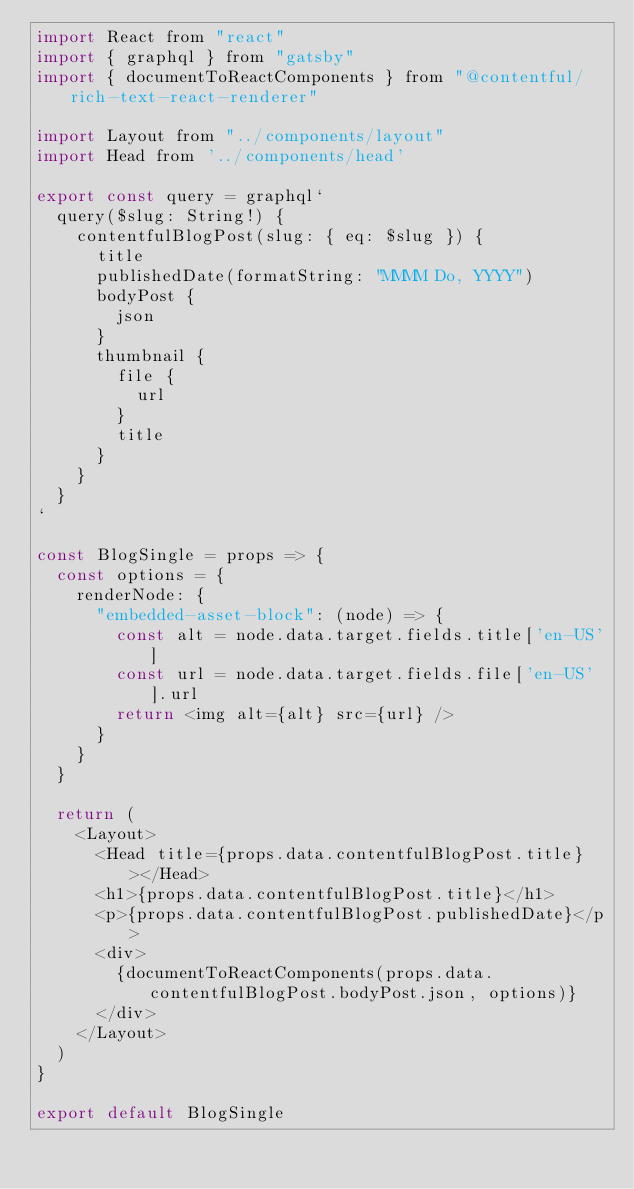<code> <loc_0><loc_0><loc_500><loc_500><_JavaScript_>import React from "react"
import { graphql } from "gatsby"
import { documentToReactComponents } from "@contentful/rich-text-react-renderer"

import Layout from "../components/layout"
import Head from '../components/head'

export const query = graphql`
  query($slug: String!) {
    contentfulBlogPost(slug: { eq: $slug }) {
      title
      publishedDate(formatString: "MMMM Do, YYYY")
      bodyPost {
        json
      }
      thumbnail {
        file {
          url
        }
        title
      }
    }
  }
`

const BlogSingle = props => {
  const options = {
    renderNode: {
      "embedded-asset-block": (node) => {
        const alt = node.data.target.fields.title['en-US']
        const url = node.data.target.fields.file['en-US'].url
        return <img alt={alt} src={url} />
      }
    }
  }
  
  return (
    <Layout>
      <Head title={props.data.contentfulBlogPost.title} ></Head>
      <h1>{props.data.contentfulBlogPost.title}</h1>
      <p>{props.data.contentfulBlogPost.publishedDate}</p>
      <div>
        {documentToReactComponents(props.data.contentfulBlogPost.bodyPost.json, options)}
      </div>
    </Layout>
  )
}

export default BlogSingle
</code> 